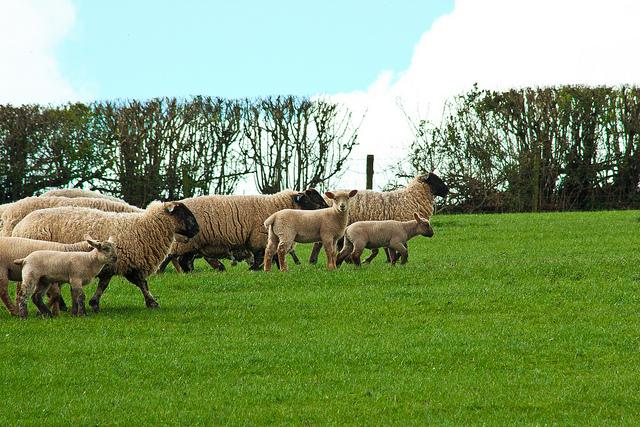Do the sheep nibble the grass?
Short answer required. No. How many sheep are racing right?
Keep it brief. 9. What are the sheep standing in?
Answer briefly. Grass. How many sheep have blackheads?
Quick response, please. 3. 